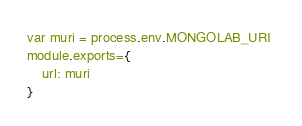<code> <loc_0><loc_0><loc_500><loc_500><_JavaScript_>var muri = process.env.MONGOLAB_URI 
module.exports={
    url: muri
}</code> 